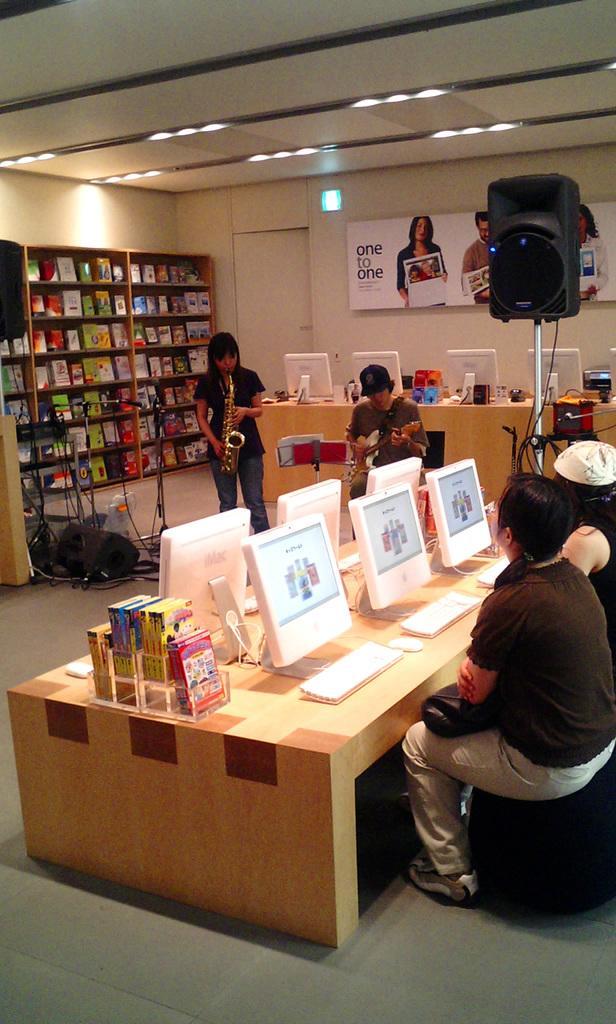Please provide a concise description of this image. It is a work place, there are lot of systems on the table and there are two people one person is standing she is playing a saxophone, to a man is sitting his playing guitar ,to their the left side there is a wardrobe there are a lot of books in it,in the background there is a white color wall, a banner, speaker, beside the banner to the left there is a door. 